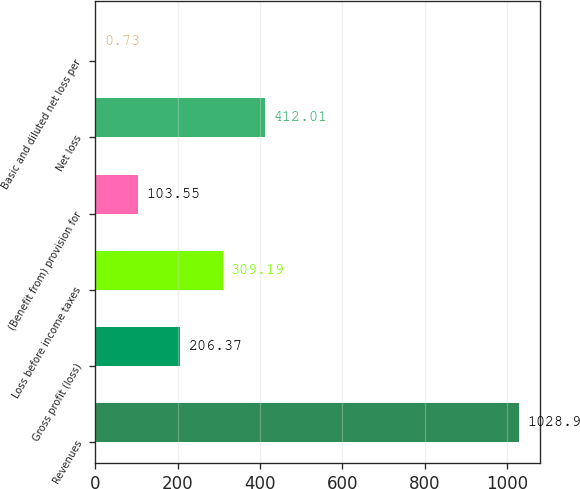<chart> <loc_0><loc_0><loc_500><loc_500><bar_chart><fcel>Revenues<fcel>Gross profit (loss)<fcel>Loss before income taxes<fcel>(Benefit from) provision for<fcel>Net loss<fcel>Basic and diluted net loss per<nl><fcel>1028.9<fcel>206.37<fcel>309.19<fcel>103.55<fcel>412.01<fcel>0.73<nl></chart> 